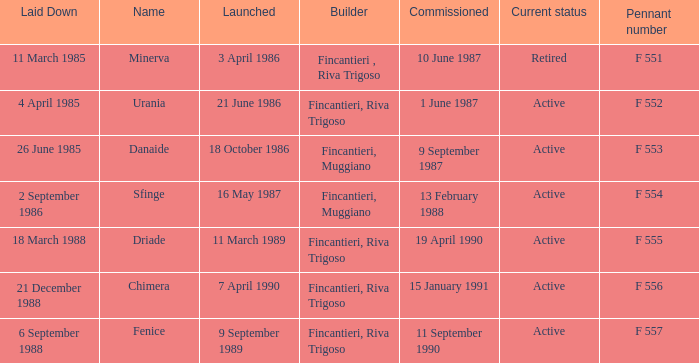Which launch date involved the Driade? 11 March 1989. 